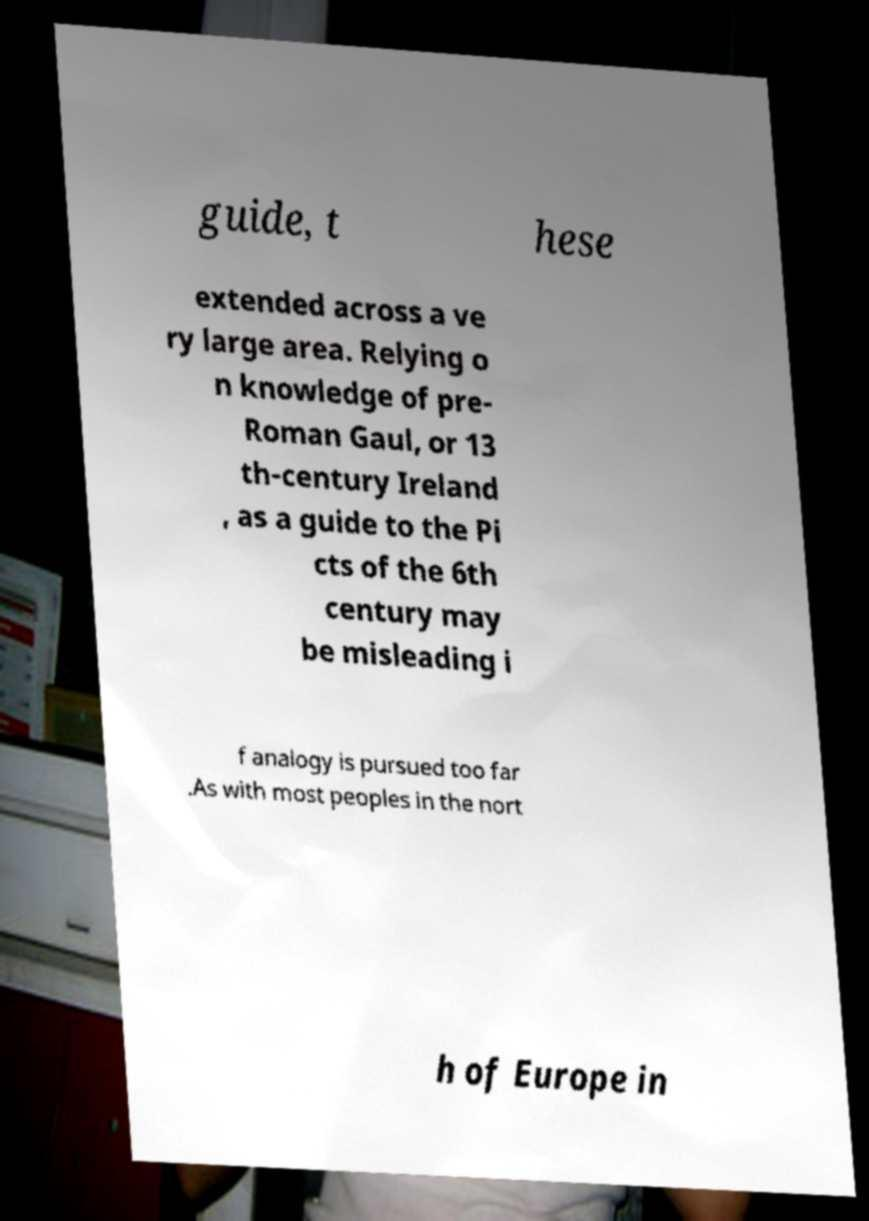Could you extract and type out the text from this image? guide, t hese extended across a ve ry large area. Relying o n knowledge of pre- Roman Gaul, or 13 th-century Ireland , as a guide to the Pi cts of the 6th century may be misleading i f analogy is pursued too far .As with most peoples in the nort h of Europe in 